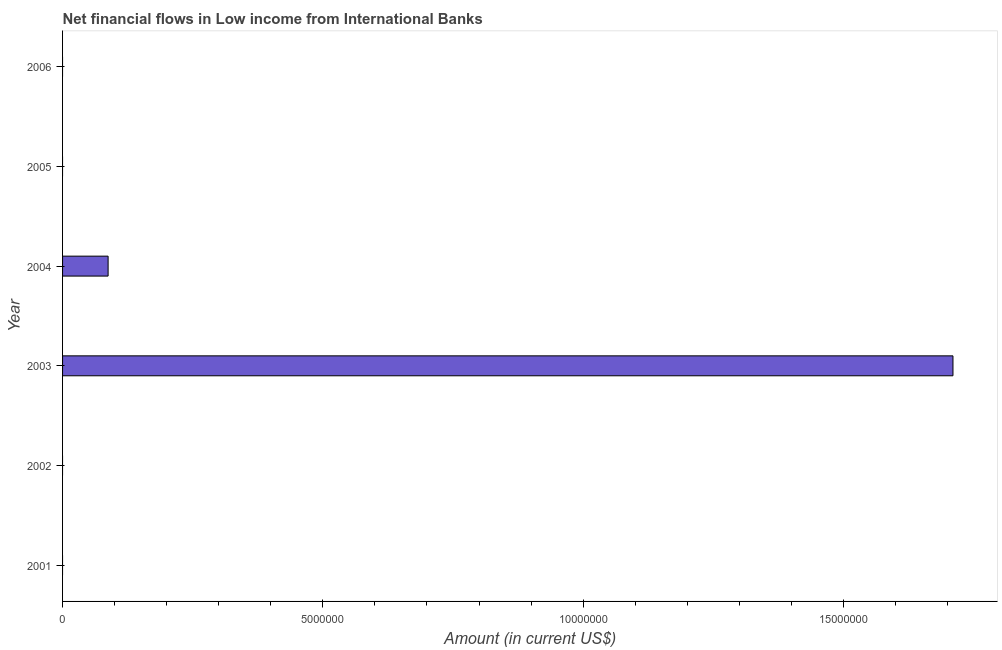What is the title of the graph?
Your answer should be very brief. Net financial flows in Low income from International Banks. What is the label or title of the X-axis?
Provide a short and direct response. Amount (in current US$). What is the label or title of the Y-axis?
Your answer should be compact. Year. Across all years, what is the maximum net financial flows from ibrd?
Offer a terse response. 1.71e+07. Across all years, what is the minimum net financial flows from ibrd?
Provide a succinct answer. 0. What is the sum of the net financial flows from ibrd?
Offer a terse response. 1.80e+07. What is the difference between the net financial flows from ibrd in 2003 and 2004?
Your response must be concise. 1.62e+07. What is the average net financial flows from ibrd per year?
Your answer should be compact. 3.00e+06. What is the median net financial flows from ibrd?
Provide a short and direct response. 0. What is the difference between the highest and the lowest net financial flows from ibrd?
Your response must be concise. 1.71e+07. How many bars are there?
Your answer should be compact. 2. How many years are there in the graph?
Give a very brief answer. 6. Are the values on the major ticks of X-axis written in scientific E-notation?
Ensure brevity in your answer.  No. What is the Amount (in current US$) in 2001?
Provide a succinct answer. 0. What is the Amount (in current US$) in 2003?
Your response must be concise. 1.71e+07. What is the Amount (in current US$) in 2004?
Provide a succinct answer. 8.75e+05. What is the Amount (in current US$) of 2005?
Keep it short and to the point. 0. What is the difference between the Amount (in current US$) in 2003 and 2004?
Provide a succinct answer. 1.62e+07. What is the ratio of the Amount (in current US$) in 2003 to that in 2004?
Your response must be concise. 19.55. 